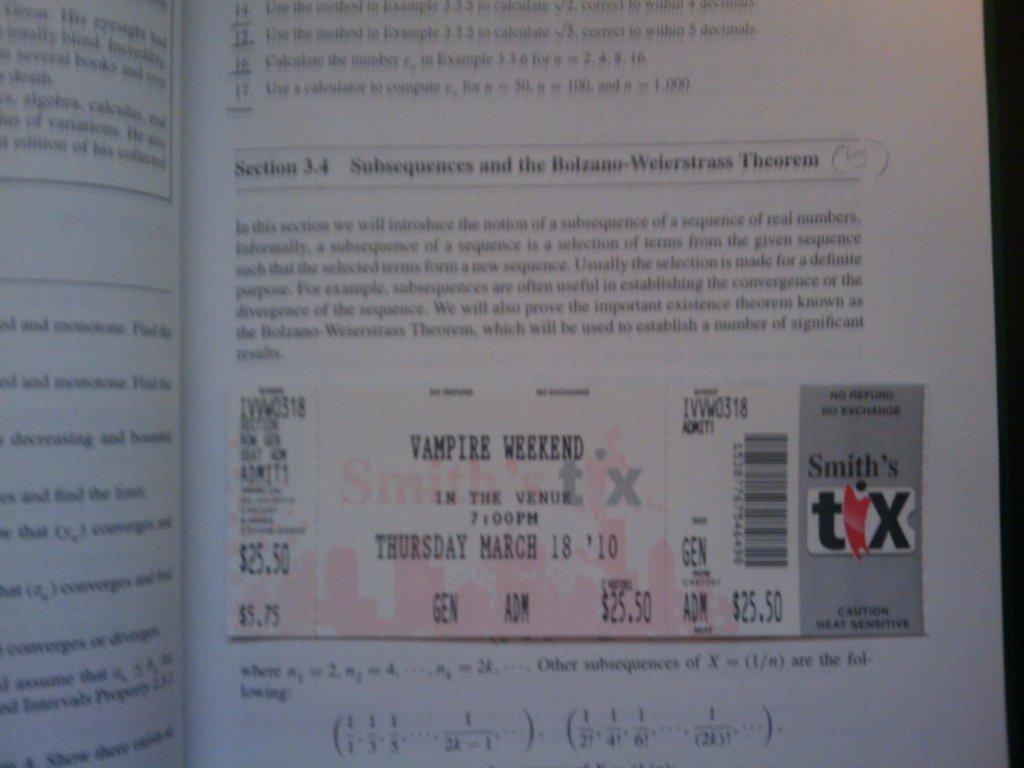<image>
Render a clear and concise summary of the photo. The ticket is good for the event called Vampire Weekend 